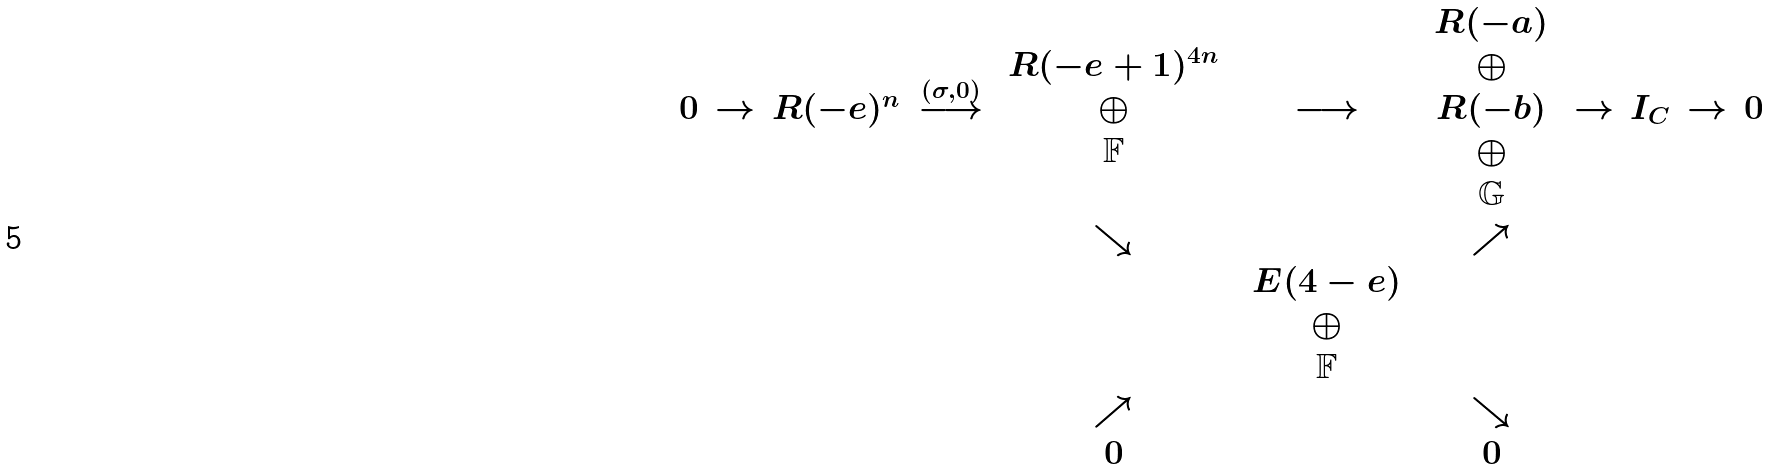<formula> <loc_0><loc_0><loc_500><loc_500>\begin{array} { c c c c c c c c c c c c c c c c c c } 0 & \rightarrow & R ( - e ) ^ { n } & \stackrel { ( \sigma , 0 ) } { \longrightarrow } & \begin{array} { c } R ( - e + 1 ) ^ { 4 n } \\ \oplus \\ { \mathbb { F } } \end{array} & \longrightarrow & \begin{array} { c } R ( - a ) \\ \oplus \\ R ( - b ) \\ \oplus \\ { \mathbb { G } } \end{array} & \rightarrow & I _ { C } & \rightarrow & 0 \\ & & & & \searrow & & \nearrow \\ & & & & & \begin{array} { c } E ( 4 - e ) \\ \oplus \\ { \mathbb { F } } \end{array} \\ & & & & \nearrow & & \searrow \\ & & & & 0 & & 0 \end{array}</formula> 